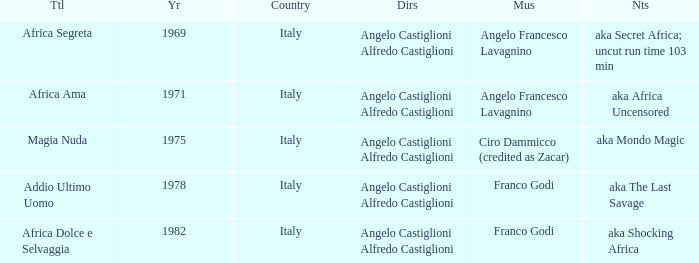How many years have a Title of Magia Nuda? 1.0. 